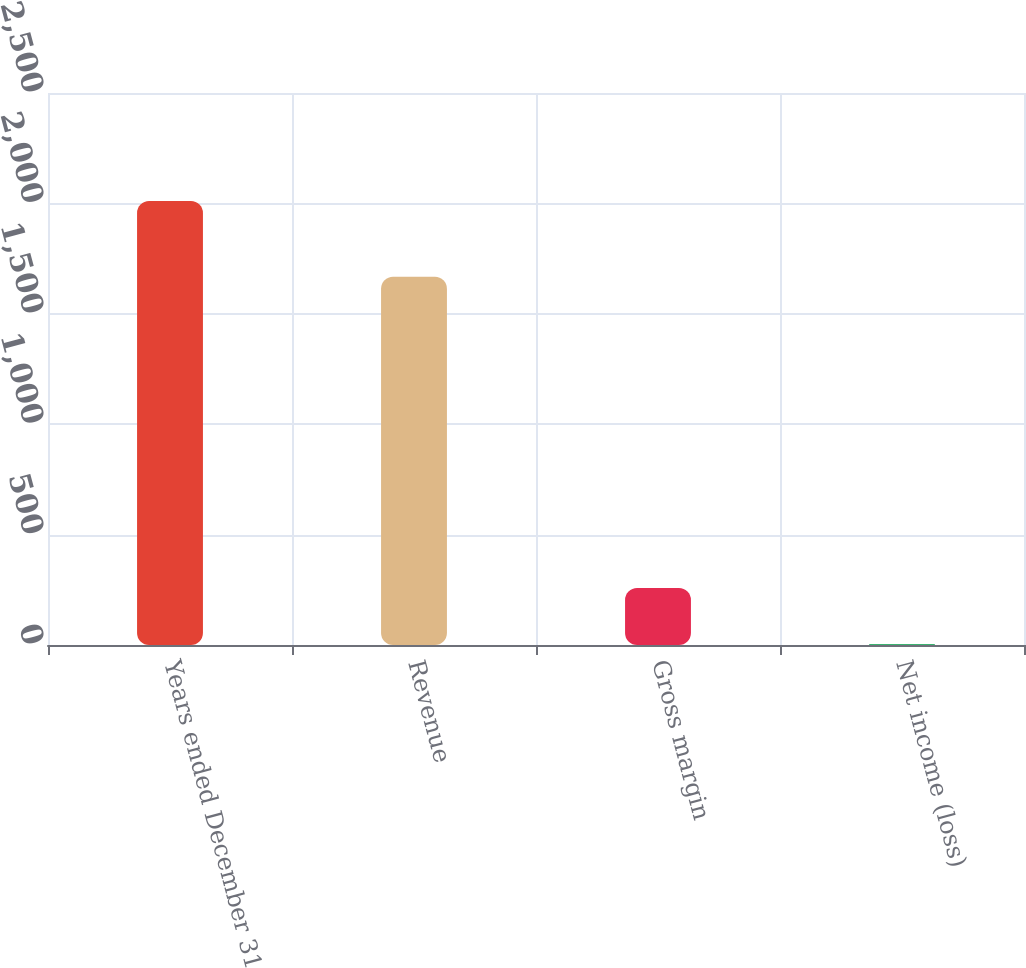Convert chart to OTSL. <chart><loc_0><loc_0><loc_500><loc_500><bar_chart><fcel>Years ended December 31<fcel>Revenue<fcel>Gross margin<fcel>Net income (loss)<nl><fcel>2011<fcel>1668<fcel>258<fcel>5<nl></chart> 